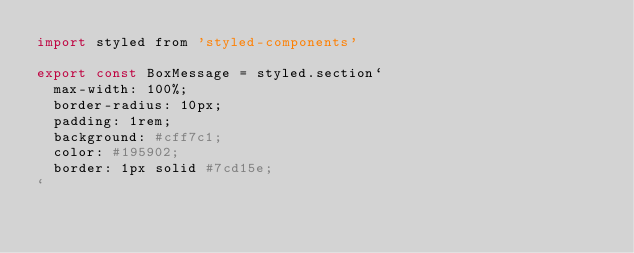<code> <loc_0><loc_0><loc_500><loc_500><_JavaScript_>import styled from 'styled-components'

export const BoxMessage = styled.section`
  max-width: 100%;
  border-radius: 10px;
  padding: 1rem;
  background: #cff7c1;
  color: #195902;
  border: 1px solid #7cd15e;
`</code> 